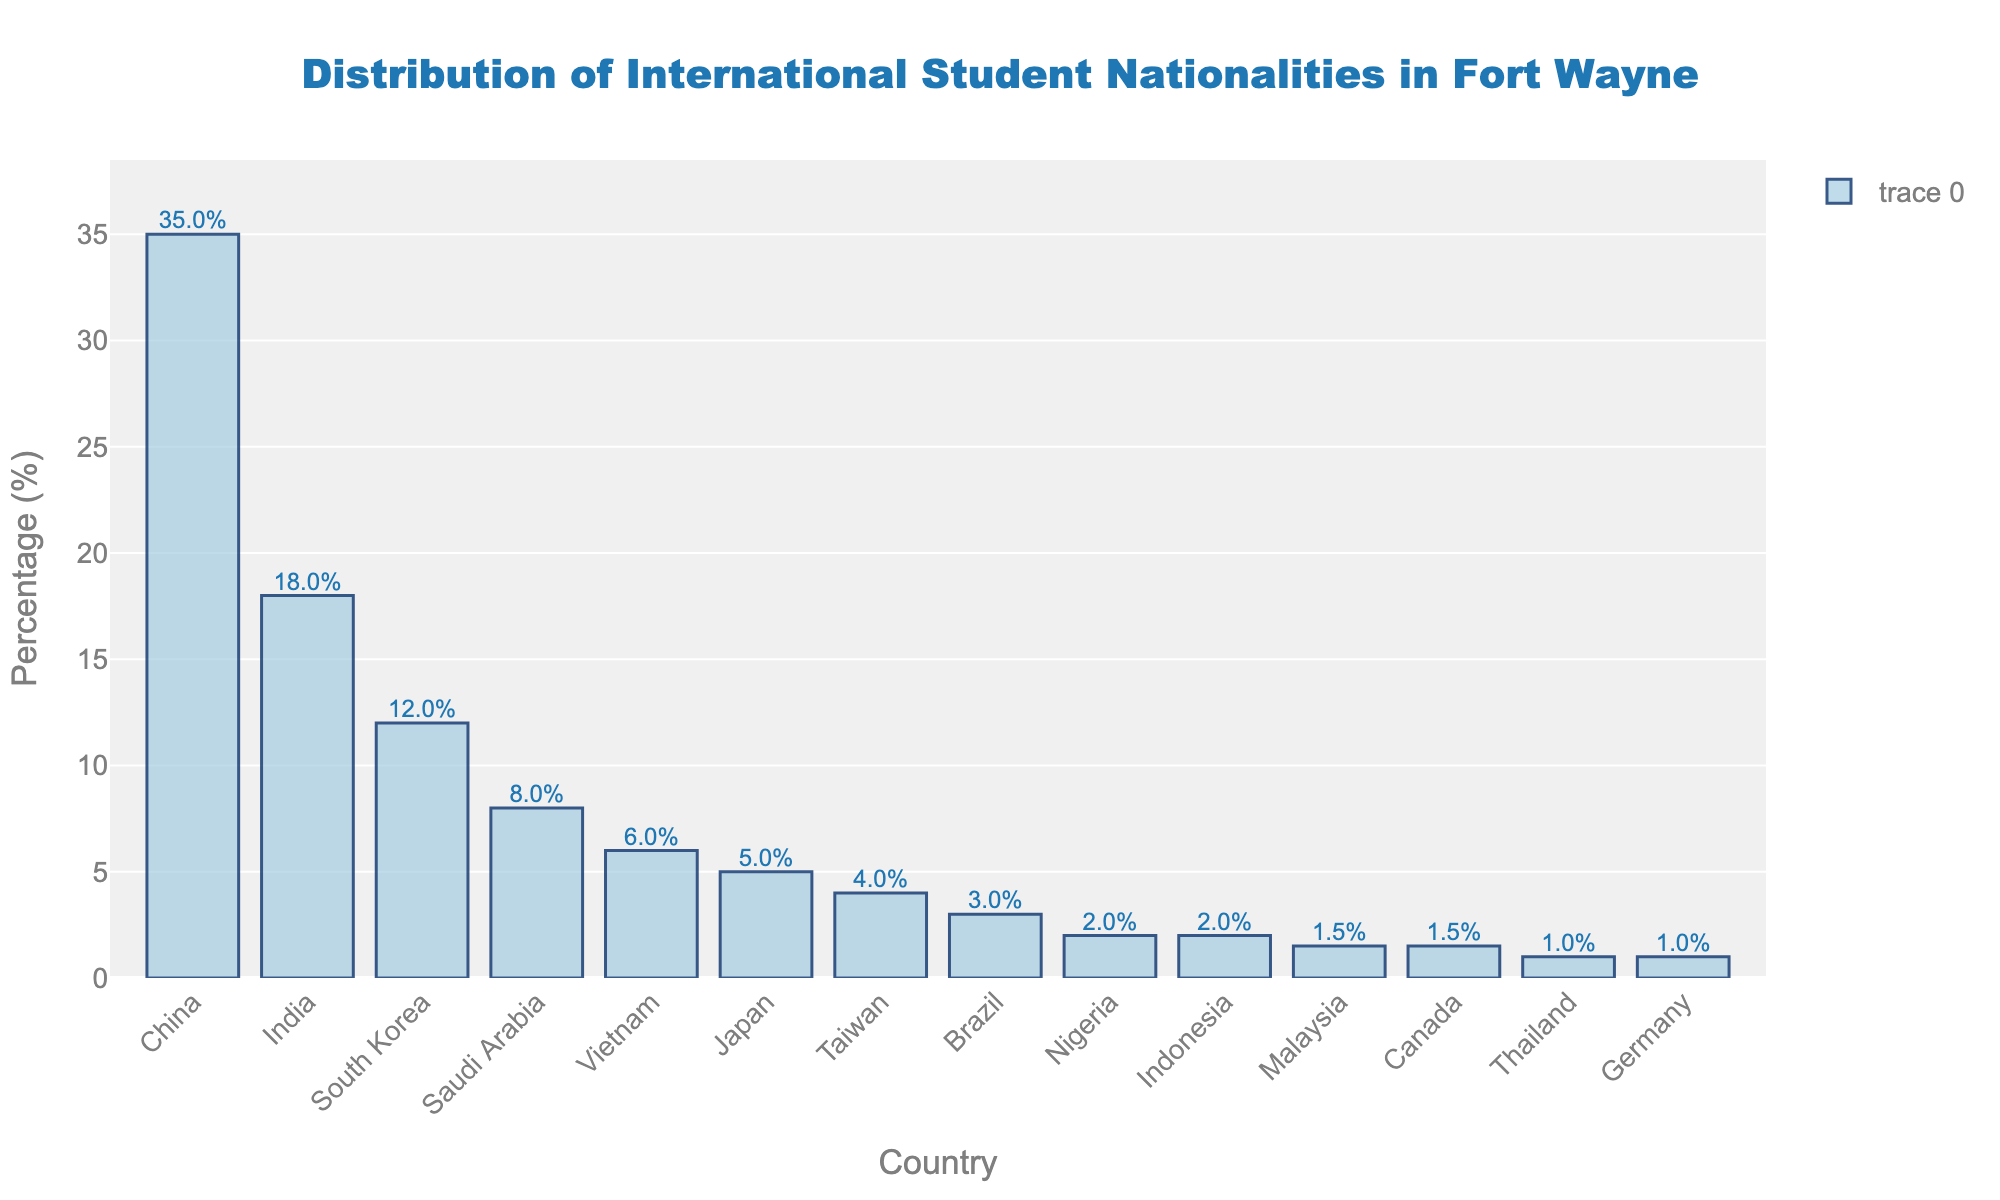Which country has the highest percentage of international students in Fort Wayne? The bar representing China is the tallest in the bar chart, indicating it has the highest percentage of international students among the listed countries.
Answer: China What is the difference in the percentage of international students between China and India? The bar for China shows 35%, and the bar for India shows 18%. The difference is calculated by subtracting India's percentage from China's percentage: 35% - 18% = 17%.
Answer: 17% How many countries have a percentage of international students that is 5% or higher? By examining the bars, we see that China, India, South Korea, Saudi Arabia, Vietnam, and Japan have percentages 5% or higher.
Answer: 6 What is the total percentage of international students from countries with less than 2% representation? The bars for Nigeria, Indonesia, Malaysia, Canada, Thailand, and Germany show 2%, 2%, 1.5%, 1.5%, 1%, and 1% respectively. Their sum is 2% + 2% + 1.5% + 1.5% + 1% + 1% = 9%.
Answer: 9% Which two countries have the closest percentage of international students, and what are their percentages? The bars for Nigeria and Indonesia both show 2%, indicating these two countries have the closest percentages.
Answer: Nigeria and Indonesia; 2% What percentage of international students come from the top three countries combined? The bars for China, India, and South Korea show 35%, 18%, and 12% respectively. Their combined percentage is 35% + 18% + 12% = 65%.
Answer: 65% How does the percentage of international students from Japan compare to that from Brazil? The bar for Japan shows 5%, and the bar for Brazil shows 3%. Japan has a higher percentage than Brazil.
Answer: Japan has a higher percentage What is the relation between the bar heights of South Korea and Vietnam? The bar for South Korea is taller than the bar for Vietnam, indicating that South Korea has a higher percentage of international students compared to Vietnam.
Answer: South Korea > Vietnam What is the average percentage of international students from China, India, and Saudi Arabia? The bars show China has 35%, India has 18%, and Saudi Arabia has 8%. The average is calculated as (35% + 18% + 8%) / 3 = 61% / 3 ≈ 20.33%.
Answer: 20.33% Which country has the lowest percentage of international students, and what is that percentage? The bar for Germany is the shortest, showing a percentage of 1%, indicating Germany has the lowest percentage of international students.
Answer: Germany; 1% 